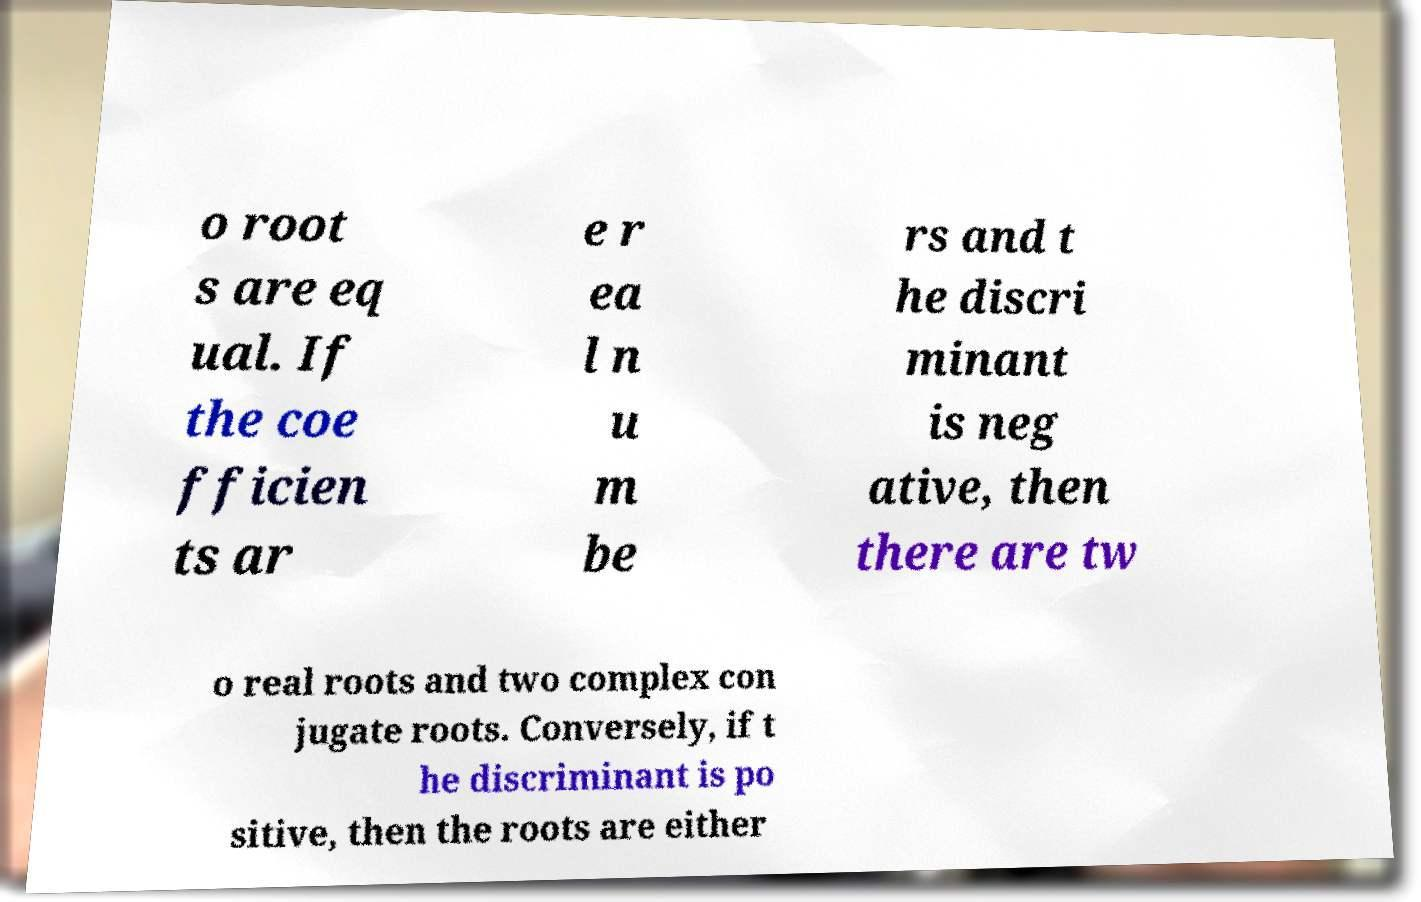I need the written content from this picture converted into text. Can you do that? o root s are eq ual. If the coe fficien ts ar e r ea l n u m be rs and t he discri minant is neg ative, then there are tw o real roots and two complex con jugate roots. Conversely, if t he discriminant is po sitive, then the roots are either 